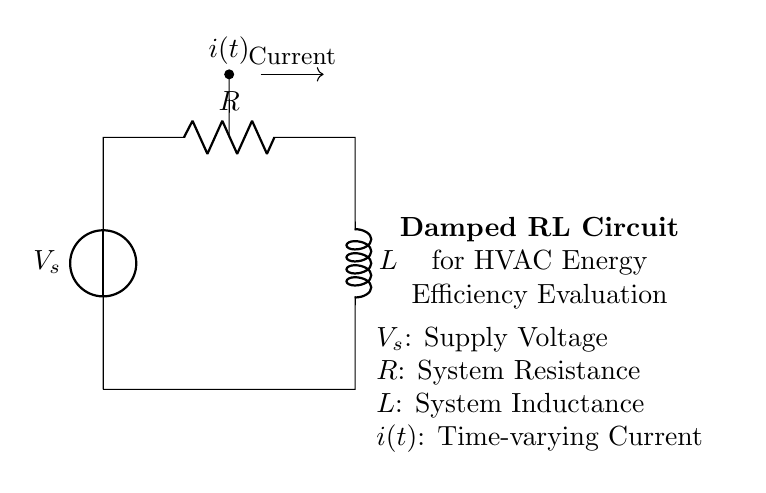What is the supply voltage in the circuit? The supply voltage is indicated as V_s, which represents the source voltage supplying the circuit.
Answer: V_s What component controls the energy dissipation in the circuit? The component that controls energy dissipation in the circuit is the resistor. It opposes the flow of current, converting electrical energy into heat.
Answer: Resistor What is the total impedance in this RL circuit? In a damped RL circuit, the total impedance is a combination of the resistance and inductive reactance. The impedance Z can be calculated using the formula Z = √(R^2 + (ωL)^2), where ω is the angular frequency.
Answer: √(R^2 + (ωL)^2) At steady state, what happens to the current in this circuit? At steady state for a damped RL circuit, the inductor behaves like a short circuit and the current reaches a constant value determined by the supply voltage and resistance. Thus, the transient response (initial changes) is removed.
Answer: Constant value What is the effect of an increase in resistance on the energy efficiency in this circuit? An increase in resistance leads to more energy being dissipated as heat according to Joule's law (I^2R). This reduces the overall energy efficiency of the circuit, making it less effective in performing work.
Answer: Reduced efficiency Which component stores energy in the circuit? The component that stores energy in the circuit is the inductor. The inductor stores energy in its magnetic field when current flows through it.
Answer: Inductor What happens to the current over time in a damped RL circuit? In a damped RL circuit, the current decreases over time due to energy being dissipated in the resistor. This decay process is characterized by an exponential decline, resulting in a decrease in current amplitude until it stabilizes at zero.
Answer: Decreases over time 